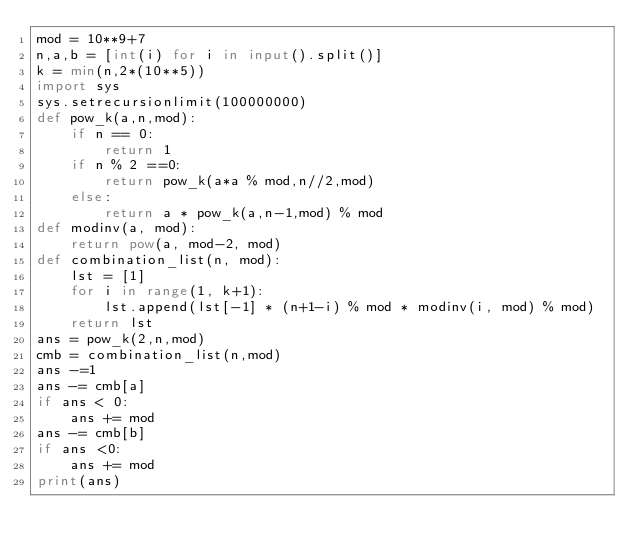Convert code to text. <code><loc_0><loc_0><loc_500><loc_500><_Python_>mod = 10**9+7
n,a,b = [int(i) for i in input().split()]
k = min(n,2*(10**5))
import sys
sys.setrecursionlimit(100000000)
def pow_k(a,n,mod):
    if n == 0:
        return 1
    if n % 2 ==0:
        return pow_k(a*a % mod,n//2,mod)
    else:
        return a * pow_k(a,n-1,mod) % mod
def modinv(a, mod):
    return pow(a, mod-2, mod)
def combination_list(n, mod):
    lst = [1]
    for i in range(1, k+1):
        lst.append(lst[-1] * (n+1-i) % mod * modinv(i, mod) % mod)
    return lst
ans = pow_k(2,n,mod)
cmb = combination_list(n,mod)
ans -=1
ans -= cmb[a]
if ans < 0:
    ans += mod
ans -= cmb[b]
if ans <0:
    ans += mod
print(ans)</code> 